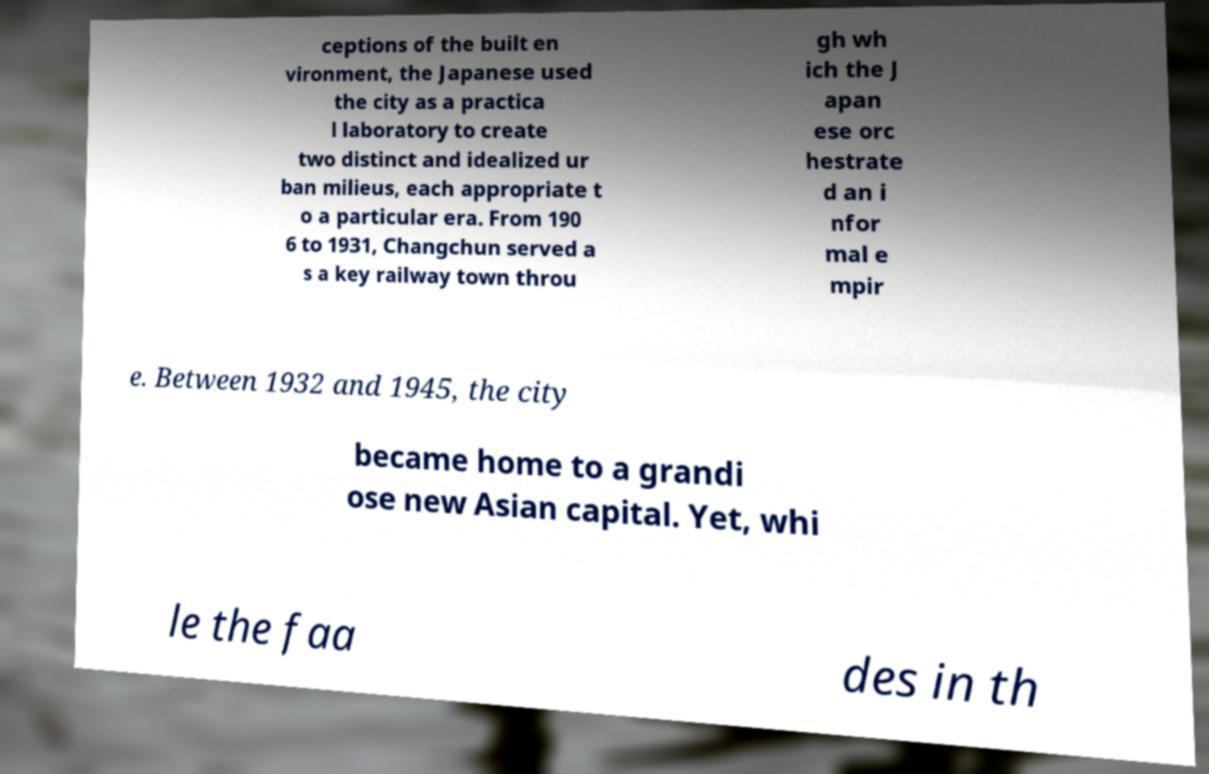There's text embedded in this image that I need extracted. Can you transcribe it verbatim? ceptions of the built en vironment, the Japanese used the city as a practica l laboratory to create two distinct and idealized ur ban milieus, each appropriate t o a particular era. From 190 6 to 1931, Changchun served a s a key railway town throu gh wh ich the J apan ese orc hestrate d an i nfor mal e mpir e. Between 1932 and 1945, the city became home to a grandi ose new Asian capital. Yet, whi le the faa des in th 